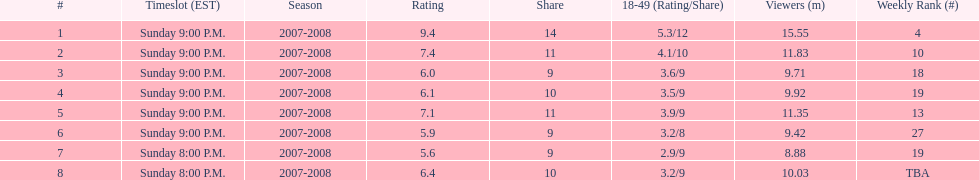The air date with the most viewers March 2, 2008. 